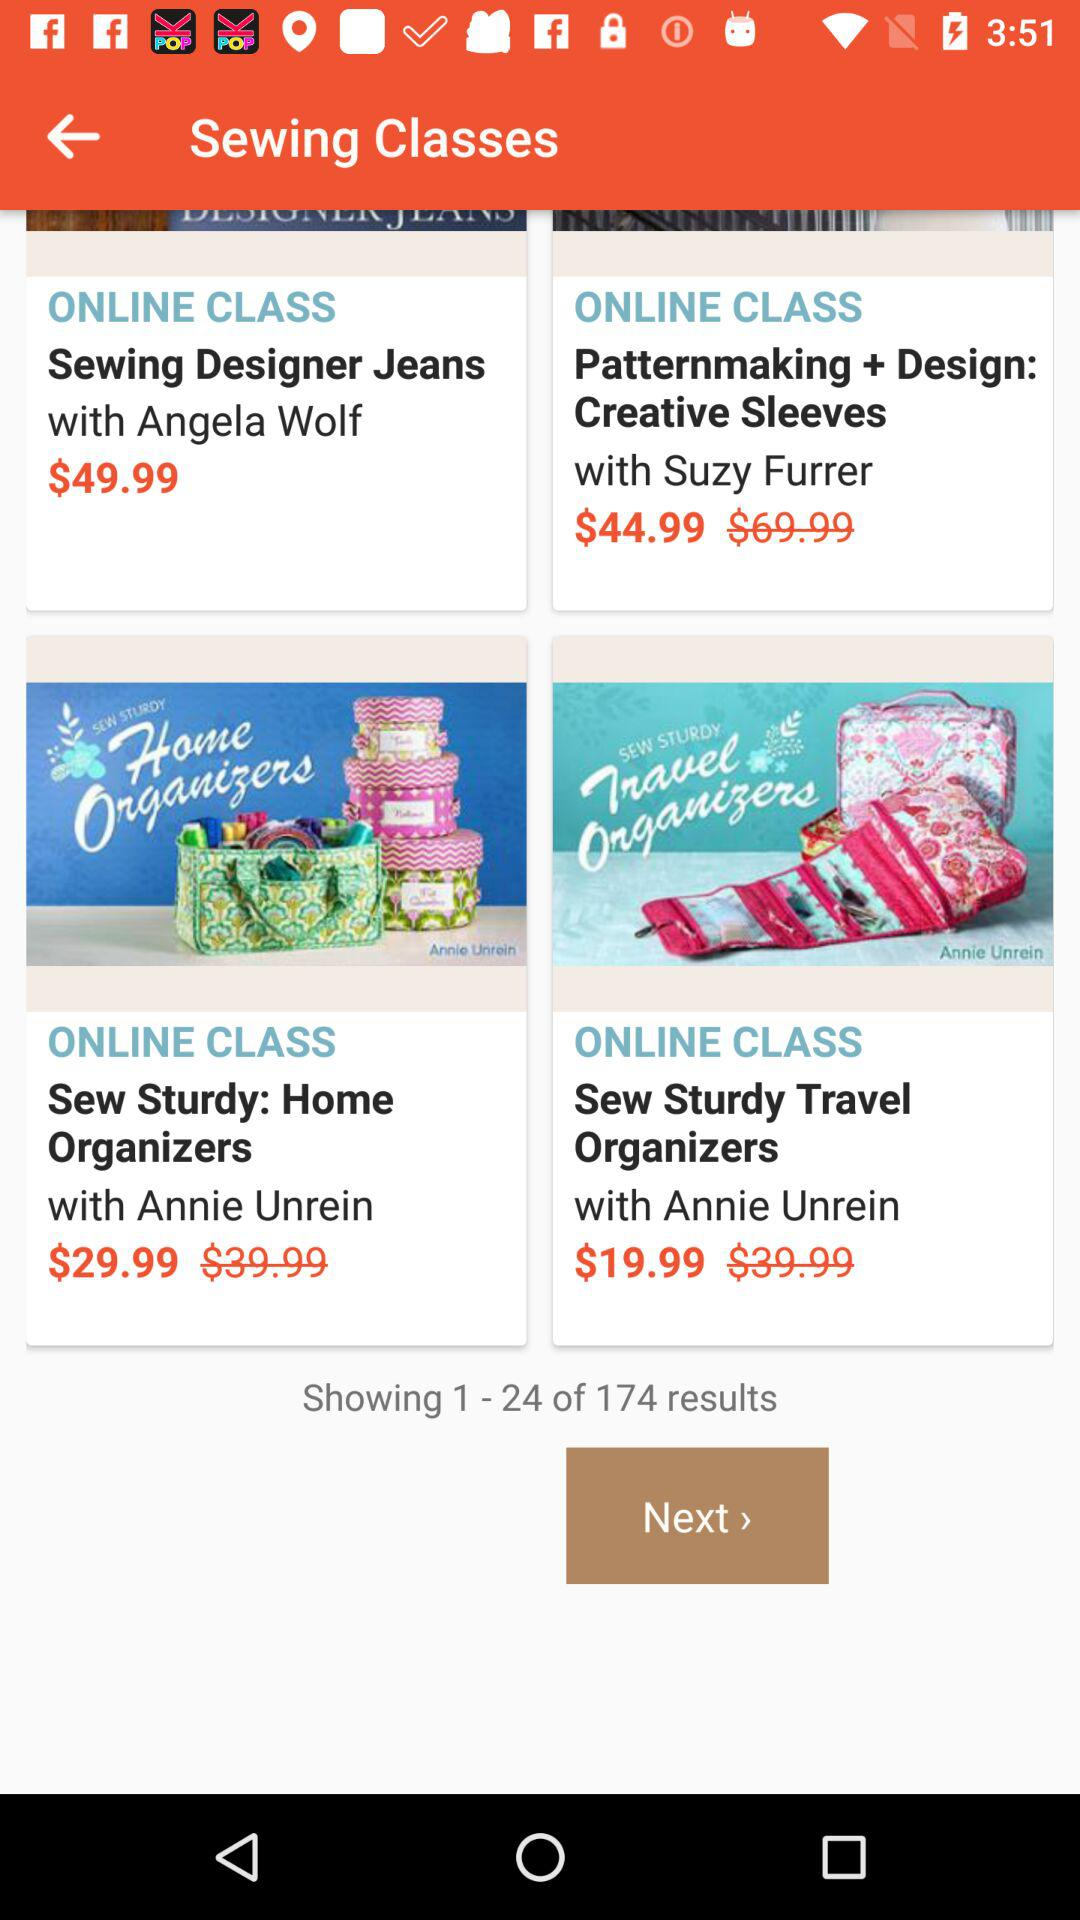How many more results are there than items shown on the first page?
Answer the question using a single word or phrase. 150 